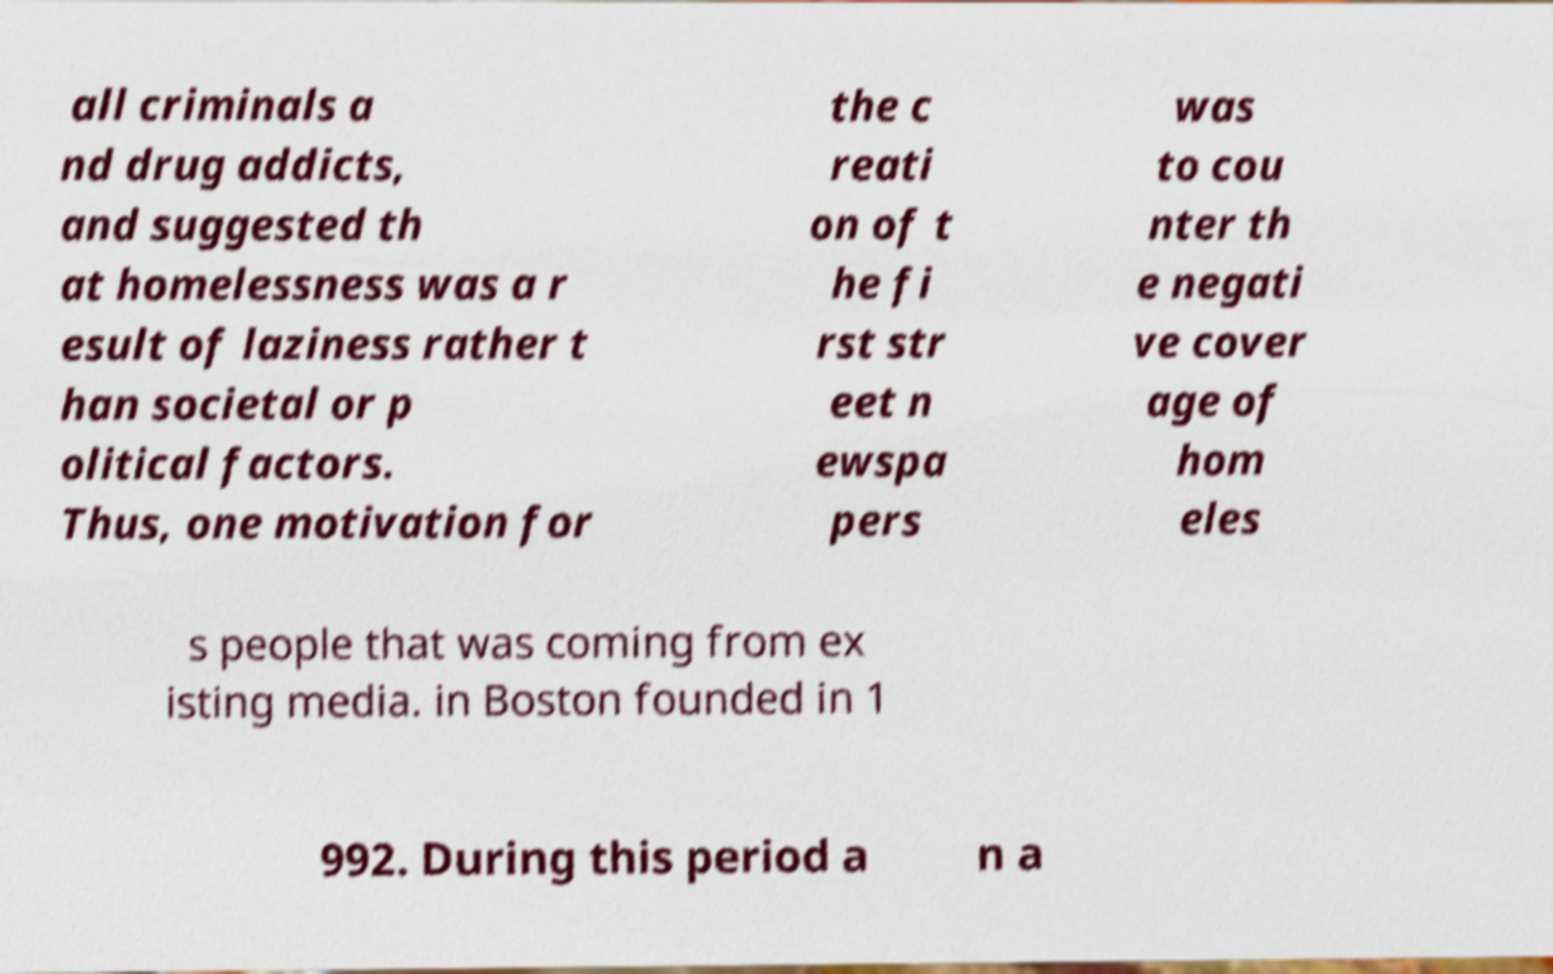Please read and relay the text visible in this image. What does it say? all criminals a nd drug addicts, and suggested th at homelessness was a r esult of laziness rather t han societal or p olitical factors. Thus, one motivation for the c reati on of t he fi rst str eet n ewspa pers was to cou nter th e negati ve cover age of hom eles s people that was coming from ex isting media. in Boston founded in 1 992. During this period a n a 